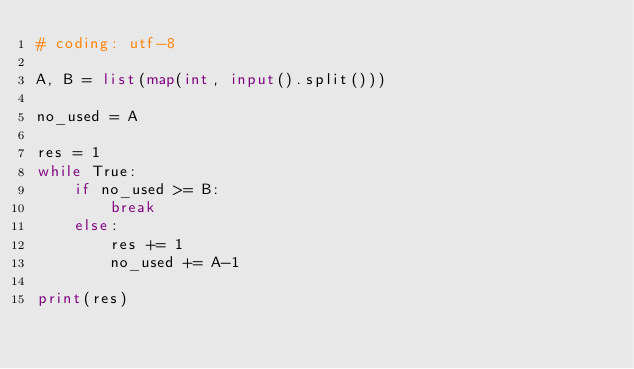<code> <loc_0><loc_0><loc_500><loc_500><_Python_># coding: utf-8

A, B = list(map(int, input().split()))

no_used = A

res = 1
while True:
    if no_used >= B:
        break
    else:
        res += 1
        no_used += A-1

print(res)</code> 